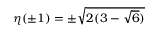Convert formula to latex. <formula><loc_0><loc_0><loc_500><loc_500>\eta ( \pm 1 ) = \pm \sqrt { 2 ( 3 - \sqrt { 6 } ) }</formula> 